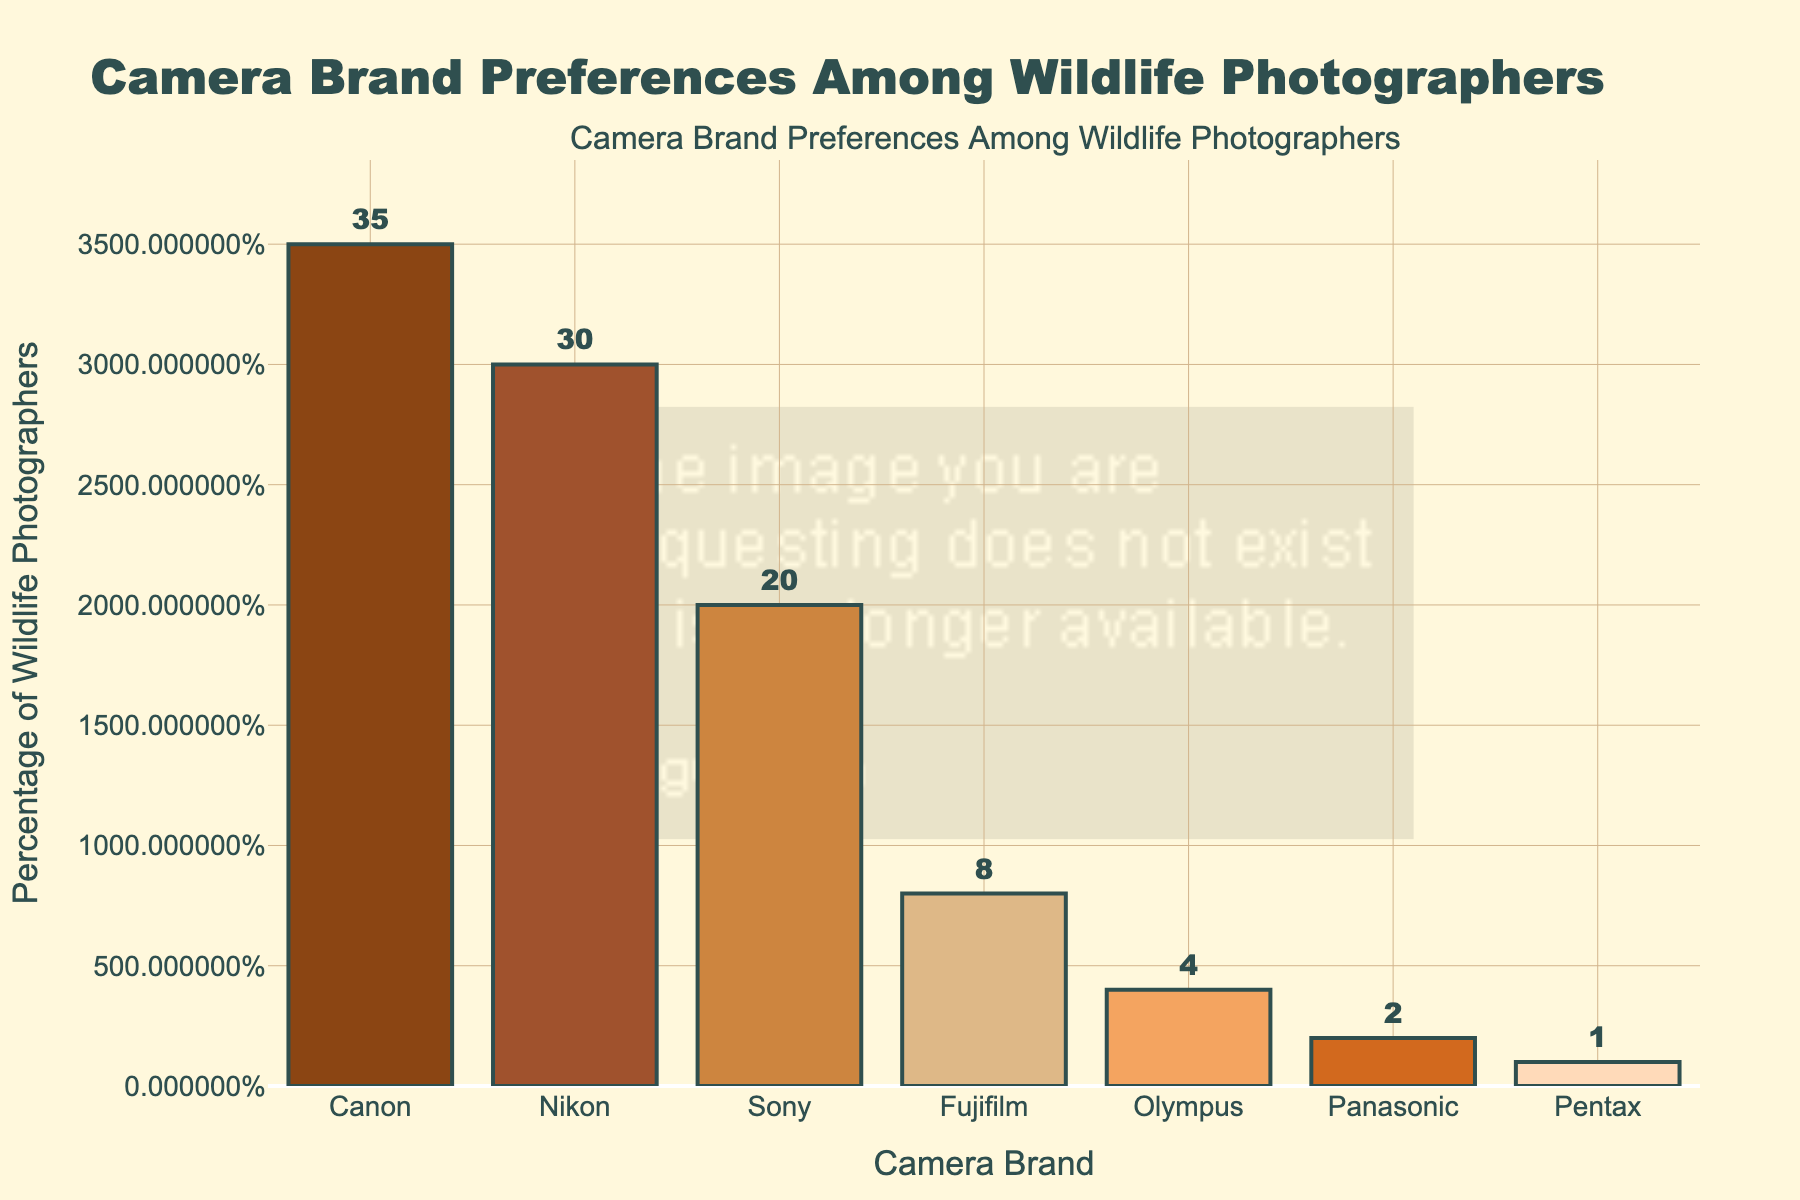Which camera brand is preferred by the highest percentage of wildlife photographers? The tallest bar represents the camera brand preferred by the highest percentage. Canon has the tallest bar at 35%.
Answer: Canon Which two camera brands combined are preferred by more than half of wildlife photographers? Adding up the percentages of the two largest bars (Canon 35% and Nikon 30%) gives 65%, which is more than 50%.
Answer: Canon and Nikon What's the difference in percentage between the most preferred and the least preferred camera brands? Subtract the percentage of the least preferred brand (Pentax, 1%) from the most preferred brand (Canon, 35%). 35% - 1% = 34%.
Answer: 34% Which camera brand is preferred by 20% of wildlife photographers? The bar representing 20% is labeled "Sony."
Answer: Sony What's the total percentage of wildlife photographers who prefer either Fujifilm or Olympus? Add the percentages for Fujifilm (8%) and Olympus (4%). 8% + 4% = 12%.
Answer: 12% How many camera brands are preferred by 10% or fewer wildlife photographers? Three bars are labeled with percentages of 10% or less: Fujifilm (8%), Olympus (4%), Panasonic (2%), and Pentax (1%).
Answer: Four Is Nikon's preference percentage more or less than the sum of preferences for Sony and Fujifilm? Compare Nikon's 30% with the sum of Sony's 20% and Fujifilm's 8%. 20% + 8% = 28%, which is less than 30%.
Answer: More Which camera brand's preference is twice that of Olympus' preference? Olympus has 4%, twice that is 8%, which is Fujifilm's percentage.
Answer: Fujifilm What is the median preference percentage among the listed camera brands? Arrange the percentages in ascending order: 1%, 2%, 4%, 8%, 20%, 30%, 35%. The middle value is 8%.
Answer: 8% What percentage more wildlife photographers prefer Canon over Sony? Subtract Sony's percentage (20%) from Canon's percentage (35%) to get the difference (15%), then divide by Sony's percentage and multiply by 100: (15% / 20%) * 100 = 75%.
Answer: 75% 